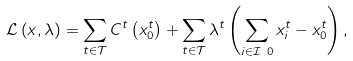Convert formula to latex. <formula><loc_0><loc_0><loc_500><loc_500>\mathcal { L } \left ( x , \lambda \right ) & = \sum _ { t \in \mathcal { T } } C ^ { t } \left ( x ^ { t } _ { 0 } \right ) + \sum _ { t \in \mathcal { T } } \lambda ^ { t } \left ( \sum _ { i \in \mathcal { I } \ 0 } x ^ { t } _ { i } - x ^ { t } _ { 0 } \right ) ,</formula> 